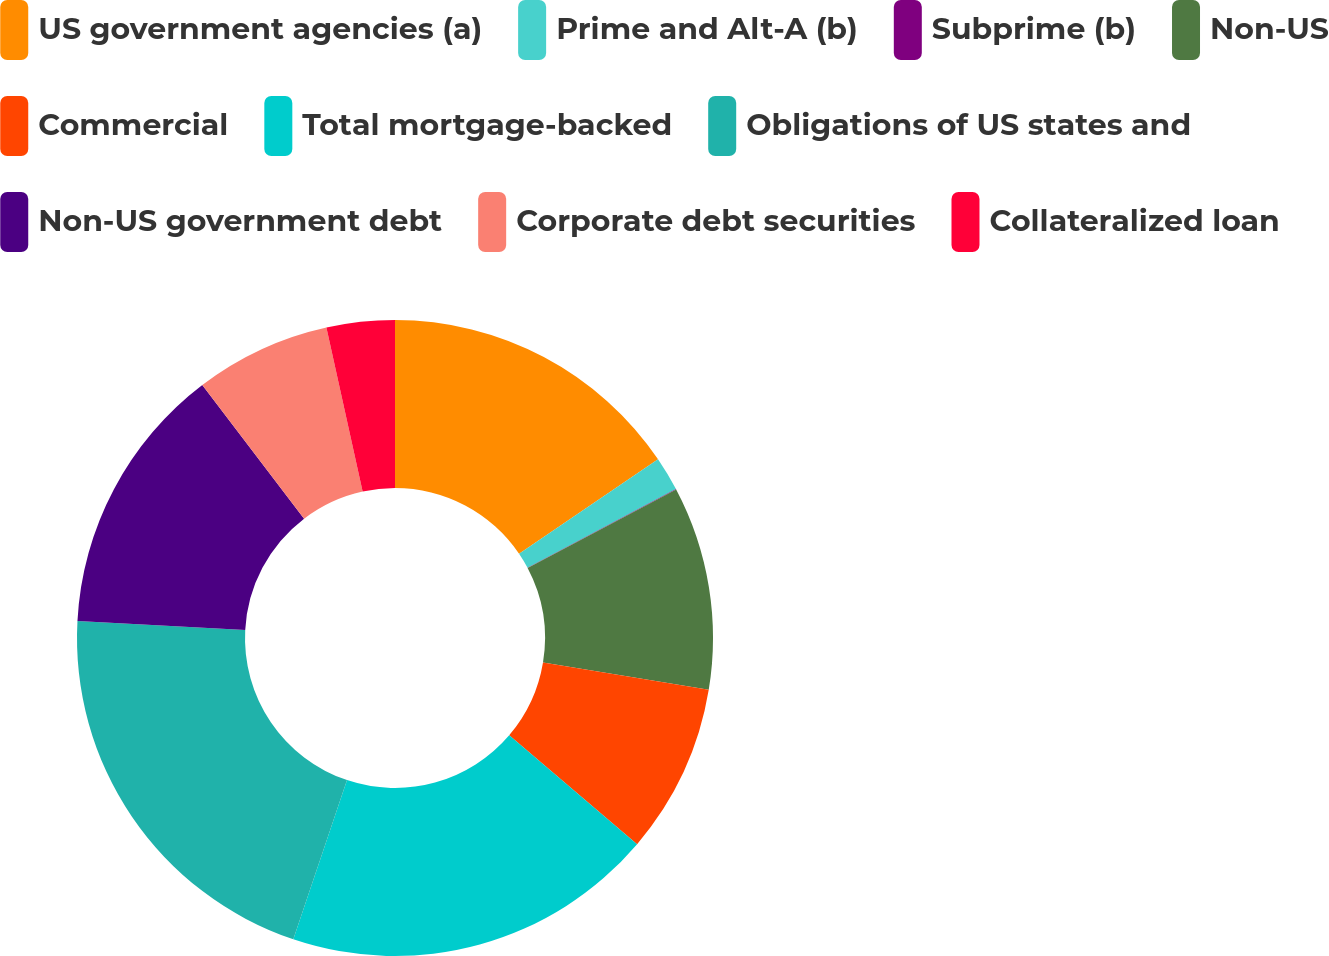Convert chart to OTSL. <chart><loc_0><loc_0><loc_500><loc_500><pie_chart><fcel>US government agencies (a)<fcel>Prime and Alt-A (b)<fcel>Subprime (b)<fcel>Non-US<fcel>Commercial<fcel>Total mortgage-backed<fcel>Obligations of US states and<fcel>Non-US government debt<fcel>Corporate debt securities<fcel>Collateralized loan<nl><fcel>15.5%<fcel>1.74%<fcel>0.02%<fcel>10.34%<fcel>8.62%<fcel>18.95%<fcel>20.67%<fcel>13.78%<fcel>6.9%<fcel>3.46%<nl></chart> 